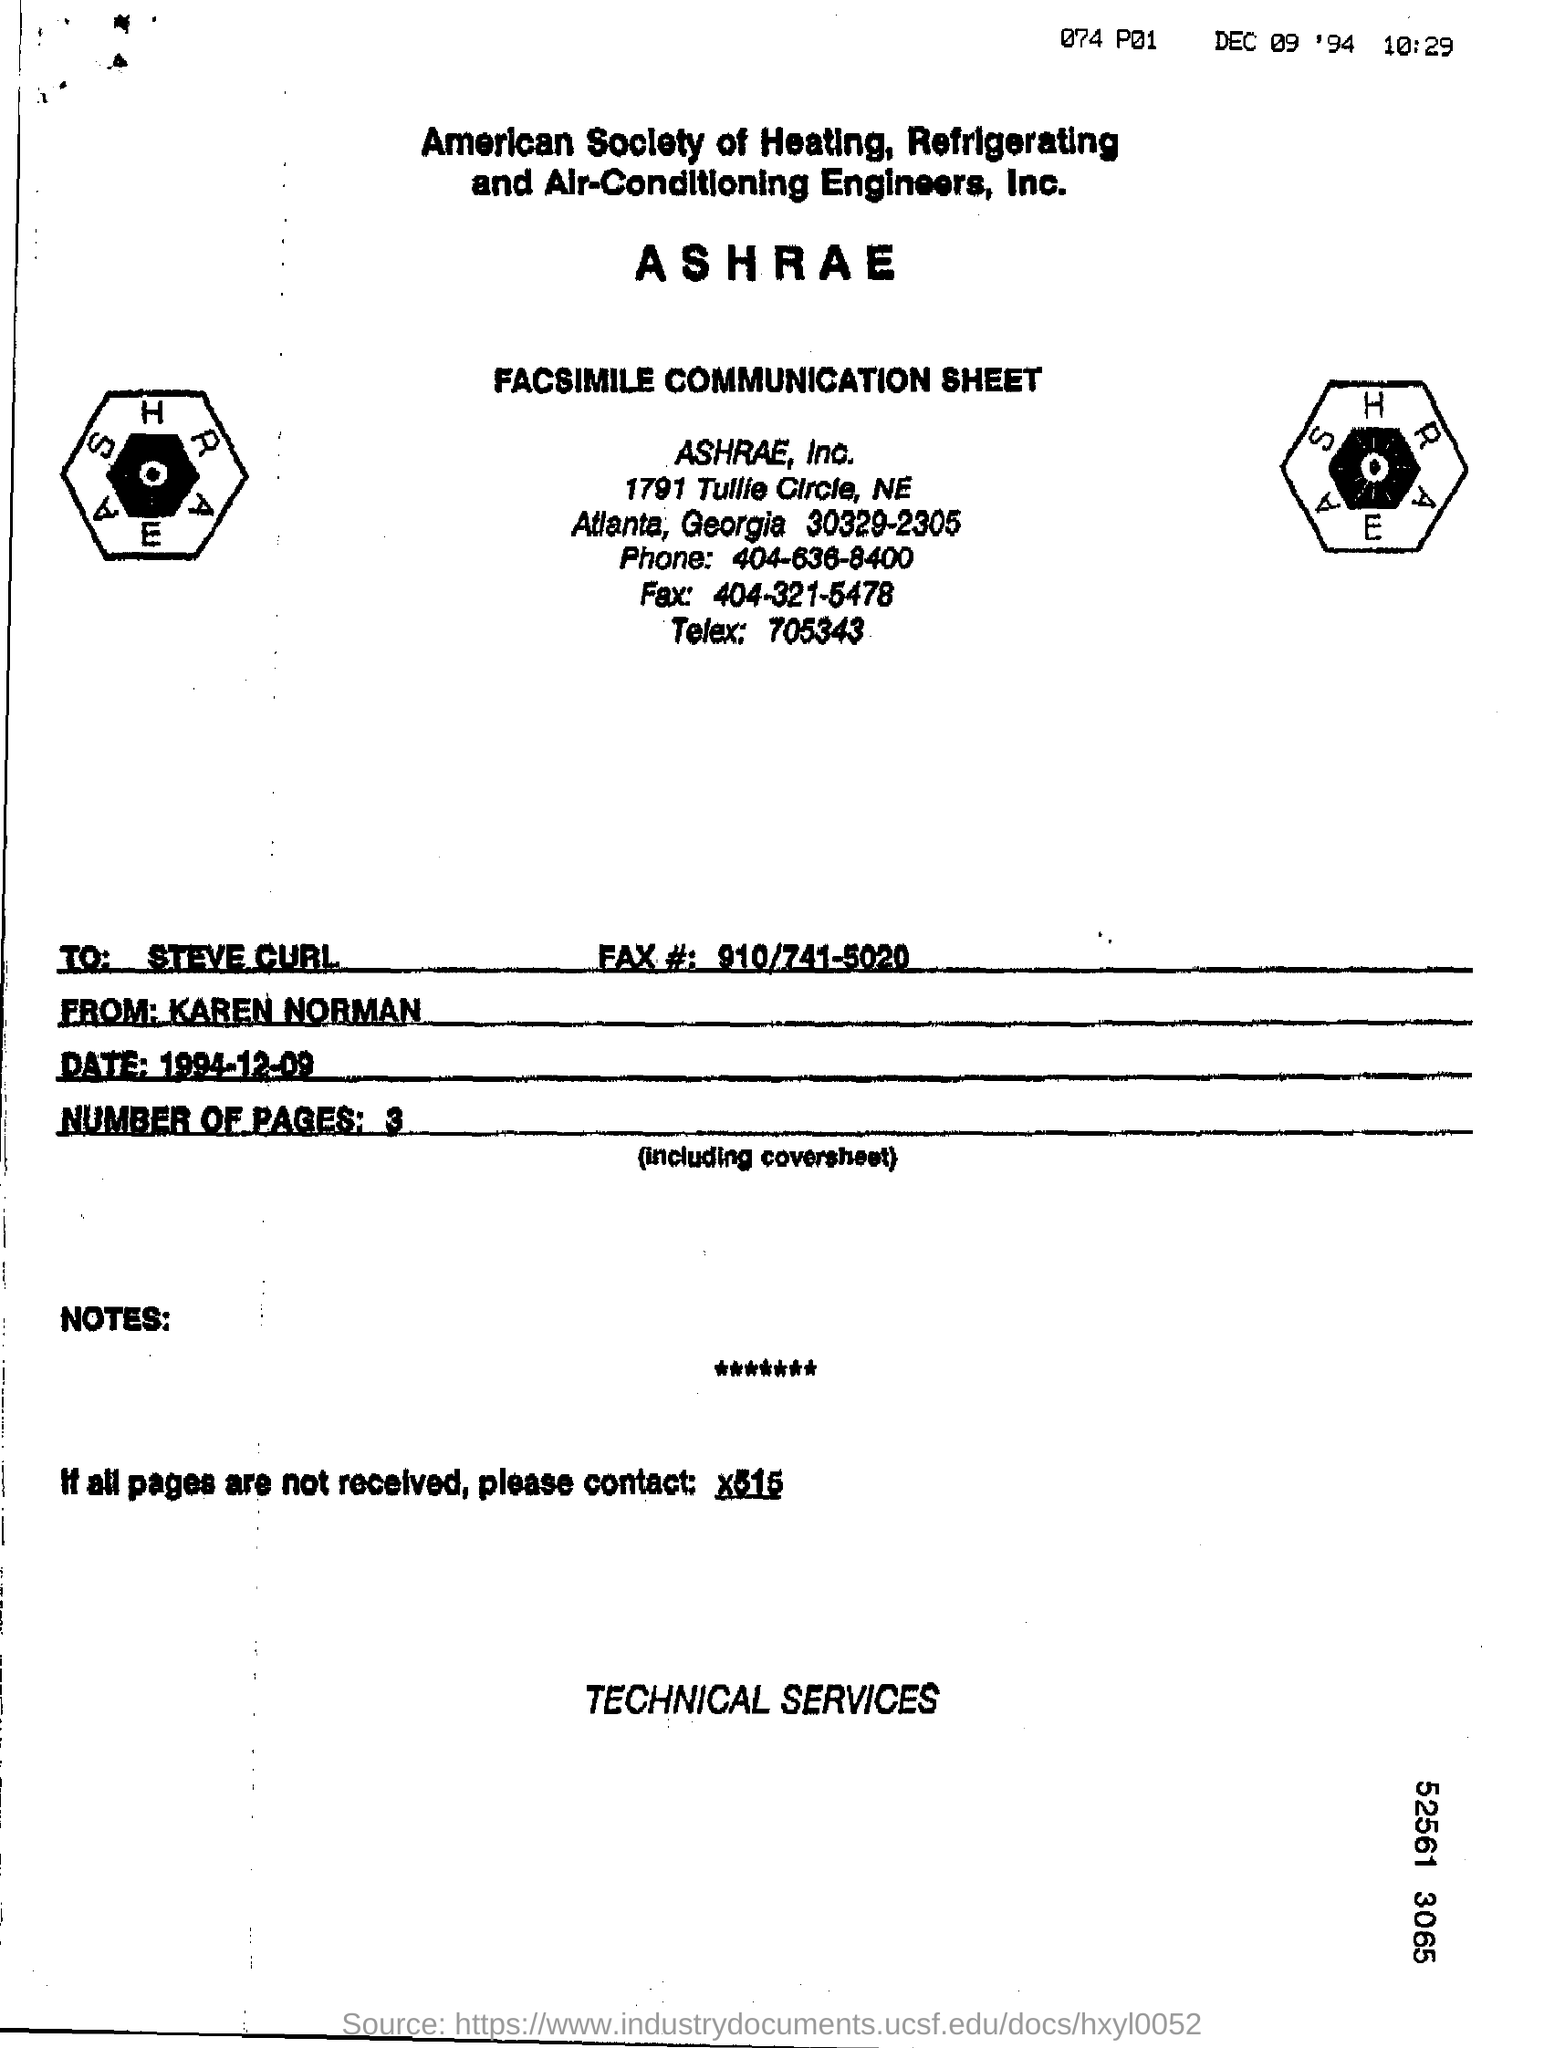What is the Sheet Name ?
Make the answer very short. FACSIMILE COMMUNICATION SHEET. Who is the recipient ?
Keep it short and to the point. Steve Curl. What is the Recipient Fax number ?
Provide a succinct answer. 910/741-5020. What date mentioned in the below the sender?
Provide a short and direct response. 1994-12-09. How many pages are there?
Your answer should be compact. 3. What is the Telex Number ?
Keep it short and to the point. 705343. What is the Phone Number ?
Give a very brief answer. 404-636-8400. 